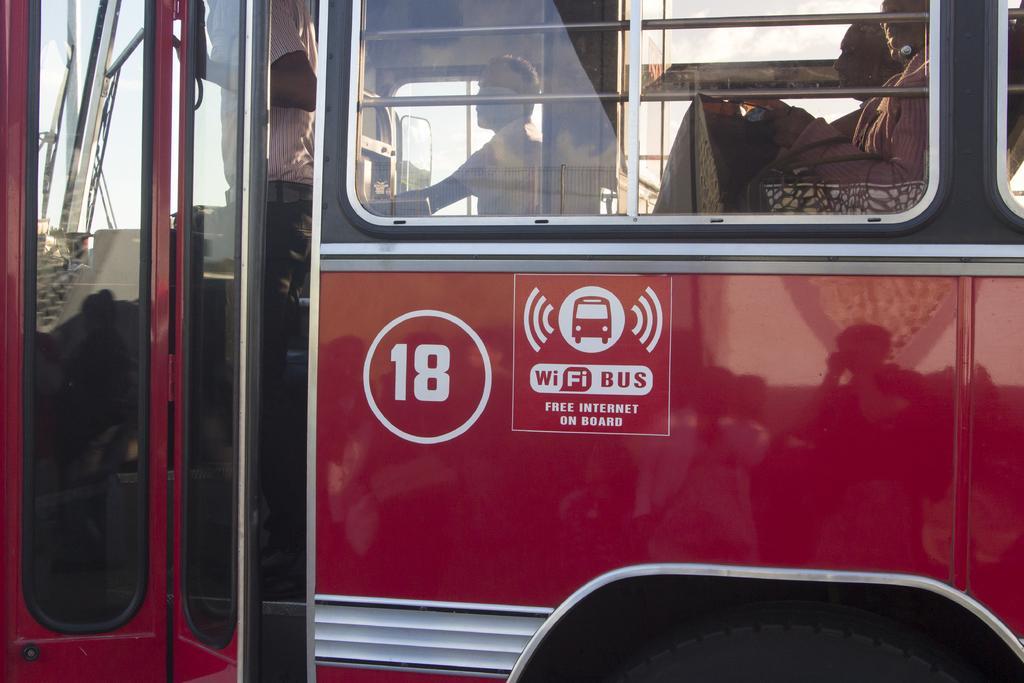Describe this image in one or two sentences. In the center of the image there is a bus. There are people sitting in bus. There is a person standing. 